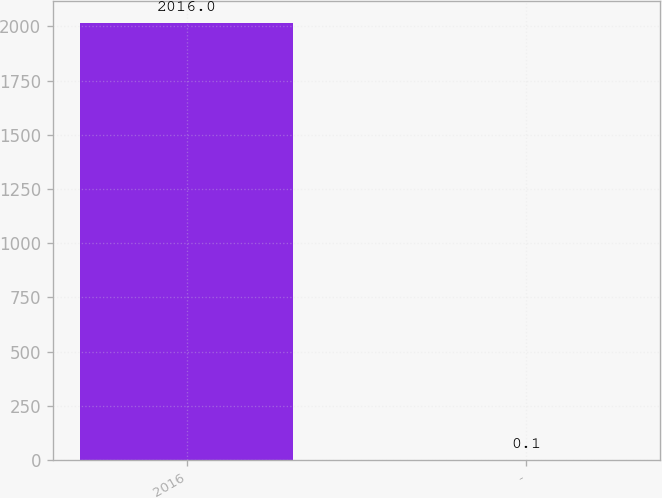Convert chart to OTSL. <chart><loc_0><loc_0><loc_500><loc_500><bar_chart><fcel>2016<fcel>-<nl><fcel>2016<fcel>0.1<nl></chart> 